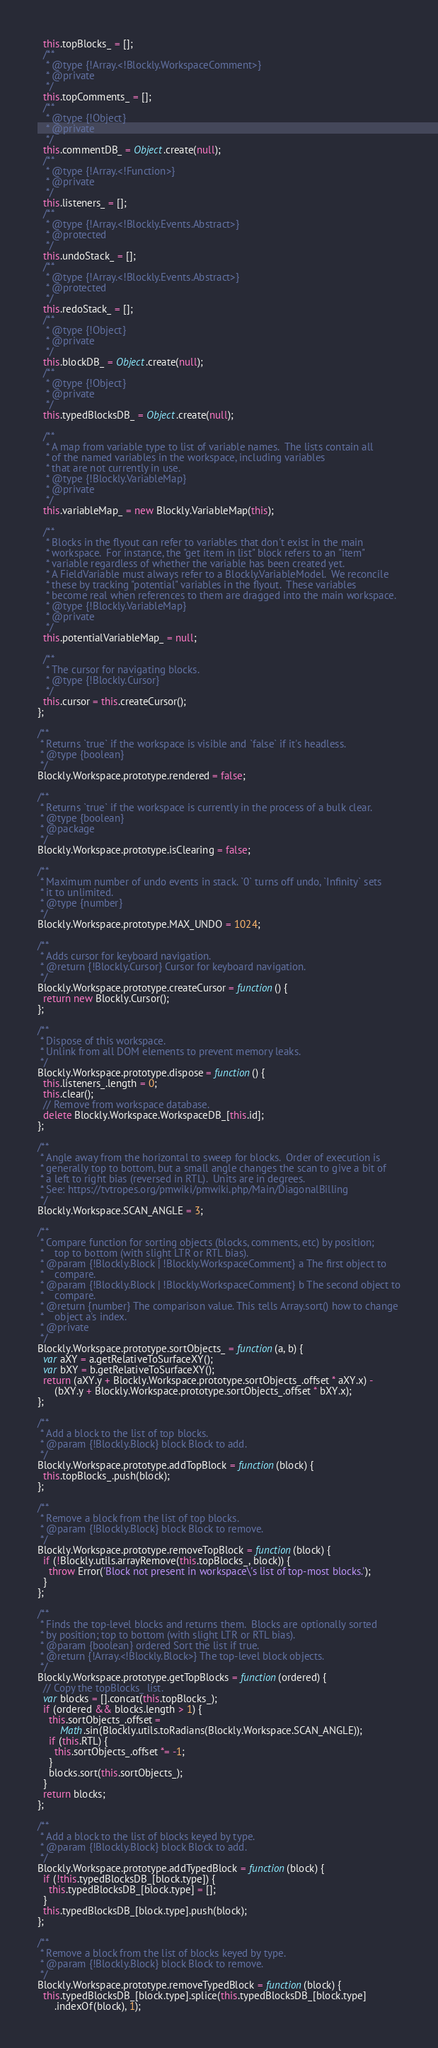Convert code to text. <code><loc_0><loc_0><loc_500><loc_500><_JavaScript_>  this.topBlocks_ = [];
  /**
   * @type {!Array.<!Blockly.WorkspaceComment>}
   * @private
   */
  this.topComments_ = [];
  /**
   * @type {!Object}
   * @private
   */
  this.commentDB_ = Object.create(null);
  /**
   * @type {!Array.<!Function>}
   * @private
   */
  this.listeners_ = [];
  /**
   * @type {!Array.<!Blockly.Events.Abstract>}
   * @protected
   */
  this.undoStack_ = [];
  /**
   * @type {!Array.<!Blockly.Events.Abstract>}
   * @protected
   */
  this.redoStack_ = [];
  /**
   * @type {!Object}
   * @private
   */
  this.blockDB_ = Object.create(null);
  /**
   * @type {!Object}
   * @private
   */
  this.typedBlocksDB_ = Object.create(null);

  /**
   * A map from variable type to list of variable names.  The lists contain all
   * of the named variables in the workspace, including variables
   * that are not currently in use.
   * @type {!Blockly.VariableMap}
   * @private
   */
  this.variableMap_ = new Blockly.VariableMap(this);

  /**
   * Blocks in the flyout can refer to variables that don't exist in the main
   * workspace.  For instance, the "get item in list" block refers to an "item"
   * variable regardless of whether the variable has been created yet.
   * A FieldVariable must always refer to a Blockly.VariableModel.  We reconcile
   * these by tracking "potential" variables in the flyout.  These variables
   * become real when references to them are dragged into the main workspace.
   * @type {!Blockly.VariableMap}
   * @private
   */
  this.potentialVariableMap_ = null;

  /**
   * The cursor for navigating blocks.
   * @type {!Blockly.Cursor}
   */
  this.cursor = this.createCursor();
};

/**
 * Returns `true` if the workspace is visible and `false` if it's headless.
 * @type {boolean}
 */
Blockly.Workspace.prototype.rendered = false;

/**
 * Returns `true` if the workspace is currently in the process of a bulk clear.
 * @type {boolean}
 * @package
 */
Blockly.Workspace.prototype.isClearing = false;

/**
 * Maximum number of undo events in stack. `0` turns off undo, `Infinity` sets
 * it to unlimited.
 * @type {number}
 */
Blockly.Workspace.prototype.MAX_UNDO = 1024;

/**
 * Adds cursor for keyboard navigation.
 * @return {!Blockly.Cursor} Cursor for keyboard navigation.
 */
Blockly.Workspace.prototype.createCursor = function() {
  return new Blockly.Cursor();
};

/**
 * Dispose of this workspace.
 * Unlink from all DOM elements to prevent memory leaks.
 */
Blockly.Workspace.prototype.dispose = function() {
  this.listeners_.length = 0;
  this.clear();
  // Remove from workspace database.
  delete Blockly.Workspace.WorkspaceDB_[this.id];
};

/**
 * Angle away from the horizontal to sweep for blocks.  Order of execution is
 * generally top to bottom, but a small angle changes the scan to give a bit of
 * a left to right bias (reversed in RTL).  Units are in degrees.
 * See: https://tvtropes.org/pmwiki/pmwiki.php/Main/DiagonalBilling
 */
Blockly.Workspace.SCAN_ANGLE = 3;

/**
 * Compare function for sorting objects (blocks, comments, etc) by position;
 *    top to bottom (with slight LTR or RTL bias).
 * @param {!Blockly.Block | !Blockly.WorkspaceComment} a The first object to
 *    compare.
 * @param {!Blockly.Block | !Blockly.WorkspaceComment} b The second object to
 *    compare.
 * @return {number} The comparison value. This tells Array.sort() how to change
 *    object a's index.
 * @private
 */
Blockly.Workspace.prototype.sortObjects_ = function(a, b) {
  var aXY = a.getRelativeToSurfaceXY();
  var bXY = b.getRelativeToSurfaceXY();
  return (aXY.y + Blockly.Workspace.prototype.sortObjects_.offset * aXY.x) -
      (bXY.y + Blockly.Workspace.prototype.sortObjects_.offset * bXY.x);
};

/**
 * Add a block to the list of top blocks.
 * @param {!Blockly.Block} block Block to add.
 */
Blockly.Workspace.prototype.addTopBlock = function(block) {
  this.topBlocks_.push(block);
};

/**
 * Remove a block from the list of top blocks.
 * @param {!Blockly.Block} block Block to remove.
 */
Blockly.Workspace.prototype.removeTopBlock = function(block) {
  if (!Blockly.utils.arrayRemove(this.topBlocks_, block)) {
    throw Error('Block not present in workspace\'s list of top-most blocks.');
  }
};

/**
 * Finds the top-level blocks and returns them.  Blocks are optionally sorted
 * by position; top to bottom (with slight LTR or RTL bias).
 * @param {boolean} ordered Sort the list if true.
 * @return {!Array.<!Blockly.Block>} The top-level block objects.
 */
Blockly.Workspace.prototype.getTopBlocks = function(ordered) {
  // Copy the topBlocks_ list.
  var blocks = [].concat(this.topBlocks_);
  if (ordered && blocks.length > 1) {
    this.sortObjects_.offset =
        Math.sin(Blockly.utils.toRadians(Blockly.Workspace.SCAN_ANGLE));
    if (this.RTL) {
      this.sortObjects_.offset *= -1;
    }
    blocks.sort(this.sortObjects_);
  }
  return blocks;
};

/**
 * Add a block to the list of blocks keyed by type.
 * @param {!Blockly.Block} block Block to add.
 */
Blockly.Workspace.prototype.addTypedBlock = function(block) {
  if (!this.typedBlocksDB_[block.type]) {
    this.typedBlocksDB_[block.type] = [];
  }
  this.typedBlocksDB_[block.type].push(block);
};

/**
 * Remove a block from the list of blocks keyed by type.
 * @param {!Blockly.Block} block Block to remove.
 */
Blockly.Workspace.prototype.removeTypedBlock = function(block) {
  this.typedBlocksDB_[block.type].splice(this.typedBlocksDB_[block.type]
      .indexOf(block), 1);</code> 